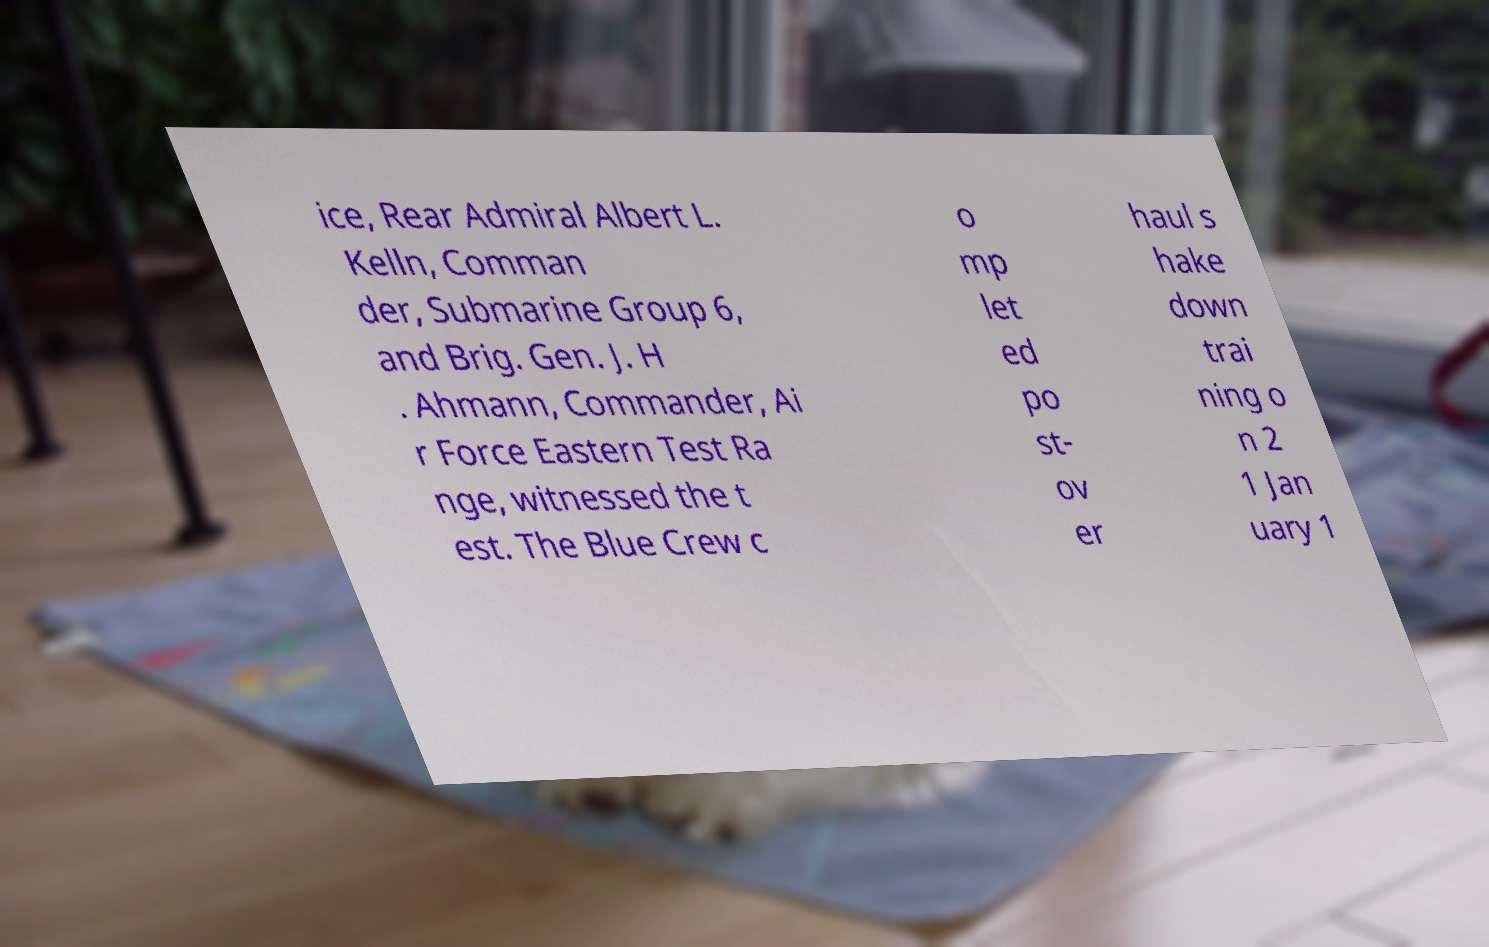Can you accurately transcribe the text from the provided image for me? ice, Rear Admiral Albert L. Kelln, Comman der, Submarine Group 6, and Brig. Gen. J. H . Ahmann, Commander, Ai r Force Eastern Test Ra nge, witnessed the t est. The Blue Crew c o mp let ed po st- ov er haul s hake down trai ning o n 2 1 Jan uary 1 